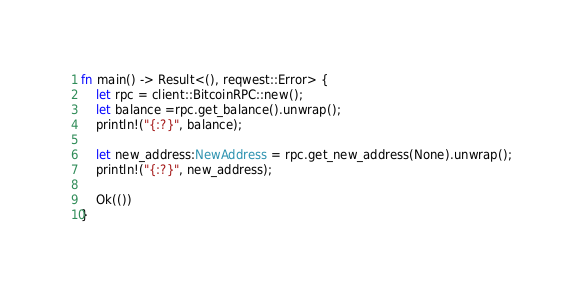Convert code to text. <code><loc_0><loc_0><loc_500><loc_500><_Rust_>fn main() -> Result<(), reqwest::Error> {
    let rpc = client::BitcoinRPC::new();
    let balance =rpc.get_balance().unwrap();
    println!("{:?}", balance);

    let new_address:NewAddress = rpc.get_new_address(None).unwrap();
    println!("{:?}", new_address);

    Ok(())
}
</code> 